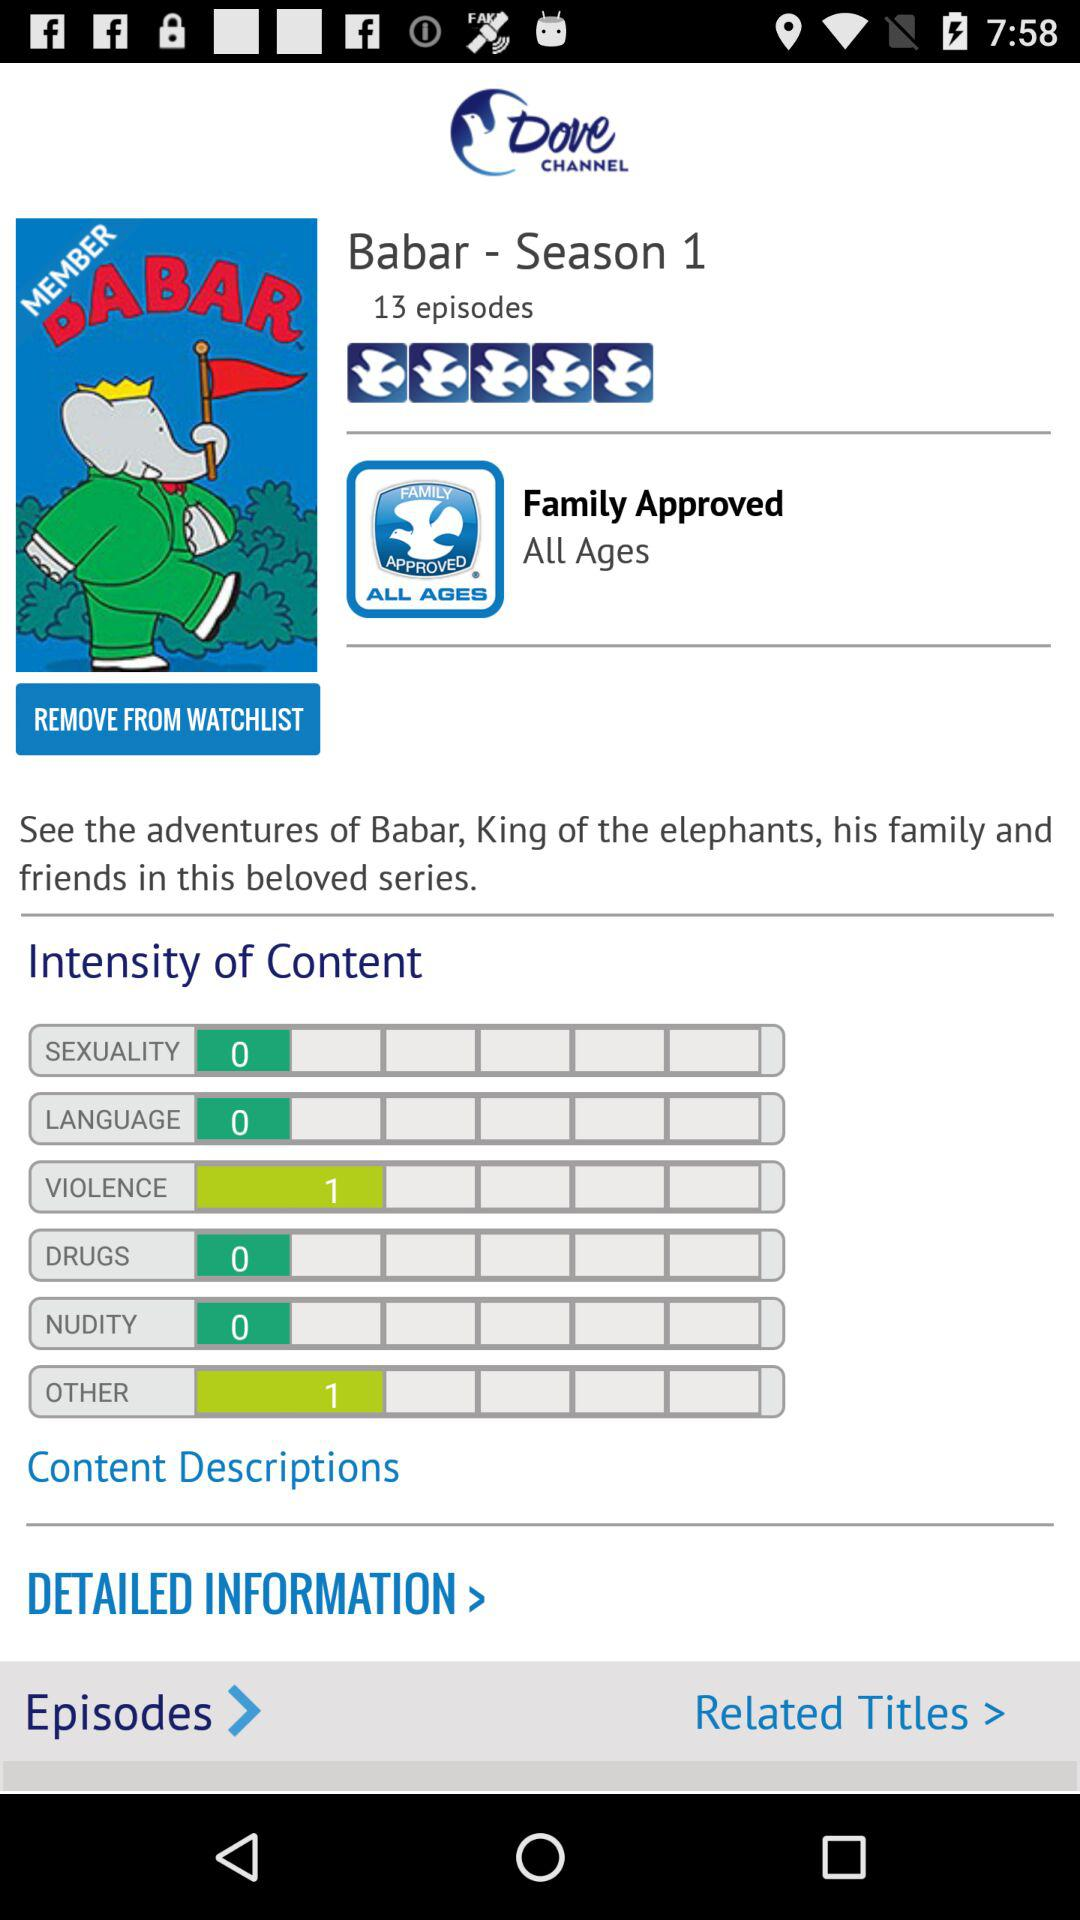What is the name of the series? The name of the series is "Babar". 